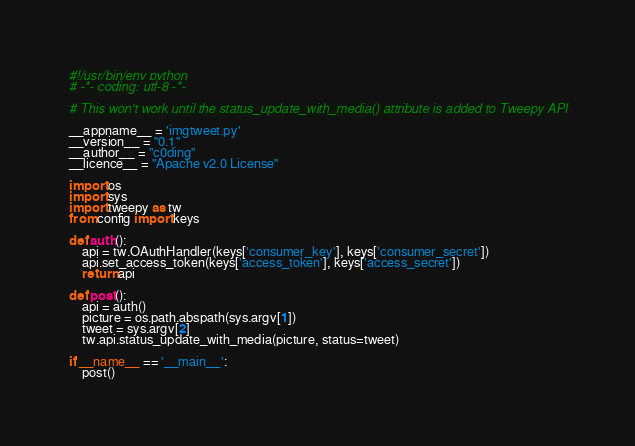Convert code to text. <code><loc_0><loc_0><loc_500><loc_500><_Python_>#!/usr/bin/env python
# -*- coding: utf-8 -*-

# This won't work until the status_update_with_media() attribute is added to Tweepy API

__appname__ = 'imgtweet.py'
__version__ = "0.1"
__author__ = "c0ding"
__licence__ = "Apache v2.0 License"

import os
import sys
import tweepy as tw
from config import keys

def auth():
	api = tw.OAuthHandler(keys['consumer_key'], keys['consumer_secret'])
	api.set_access_token(keys['access_token'], keys['access_secret'])
	return api

def post():
	api = auth()
	picture = os.path.abspath(sys.argv[1])
	tweet = sys.argv[2]
	tw.api.status_update_with_media(picture, status=tweet)
	
if __name__ == '__main__':
	post()
</code> 